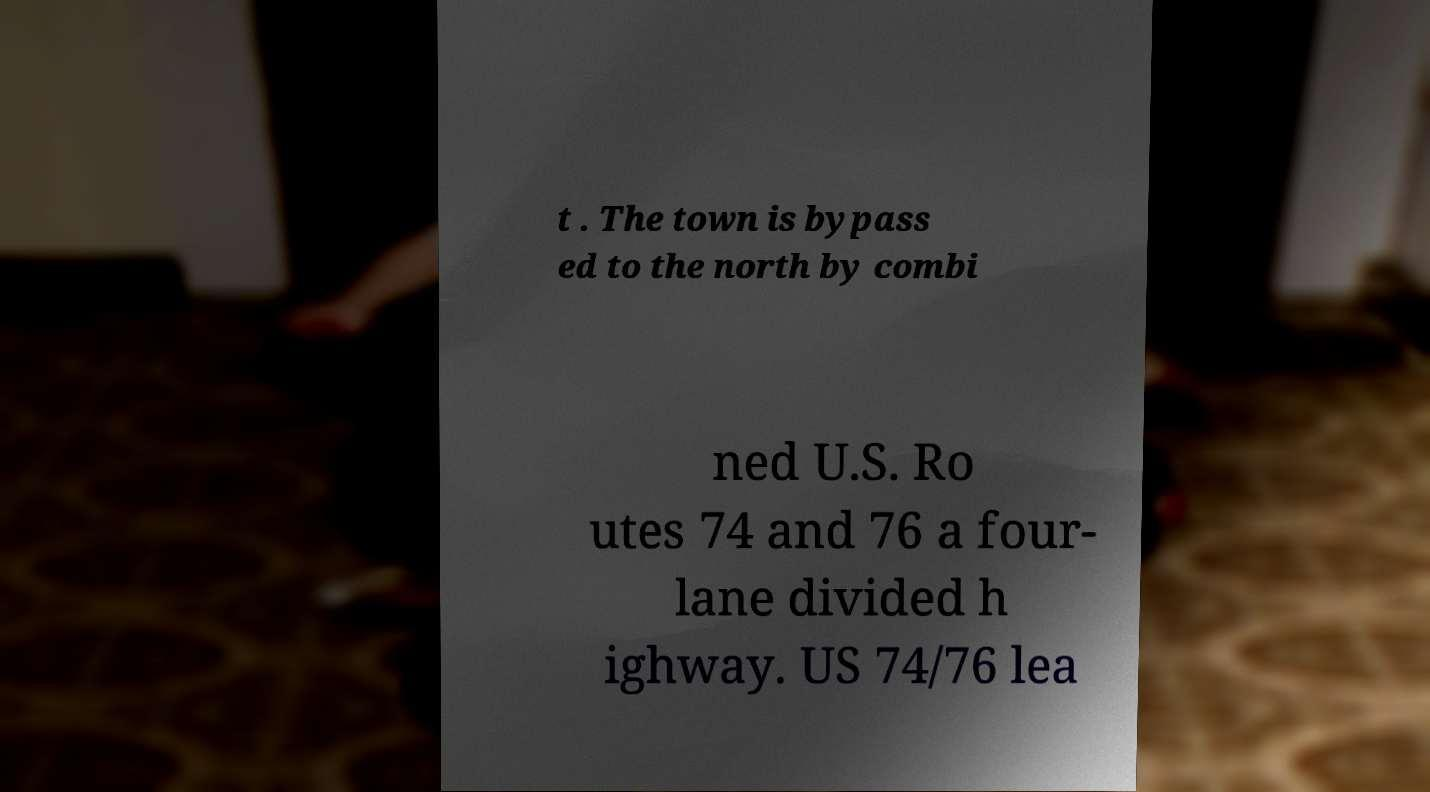Please identify and transcribe the text found in this image. t . The town is bypass ed to the north by combi ned U.S. Ro utes 74 and 76 a four- lane divided h ighway. US 74/76 lea 